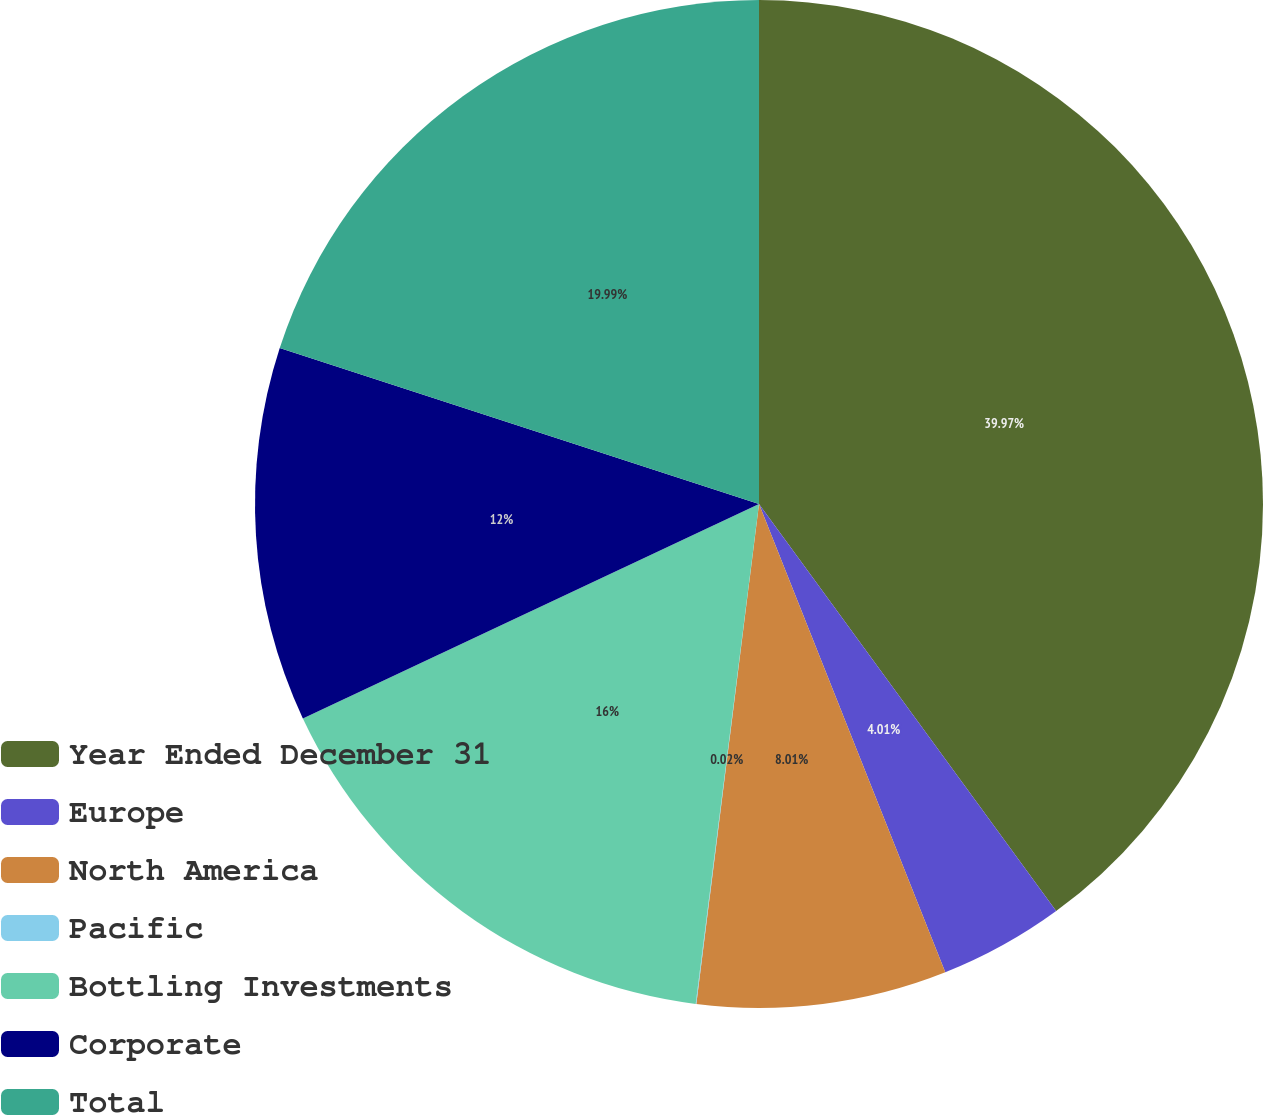Convert chart. <chart><loc_0><loc_0><loc_500><loc_500><pie_chart><fcel>Year Ended December 31<fcel>Europe<fcel>North America<fcel>Pacific<fcel>Bottling Investments<fcel>Corporate<fcel>Total<nl><fcel>39.96%<fcel>4.01%<fcel>8.01%<fcel>0.02%<fcel>16.0%<fcel>12.0%<fcel>19.99%<nl></chart> 